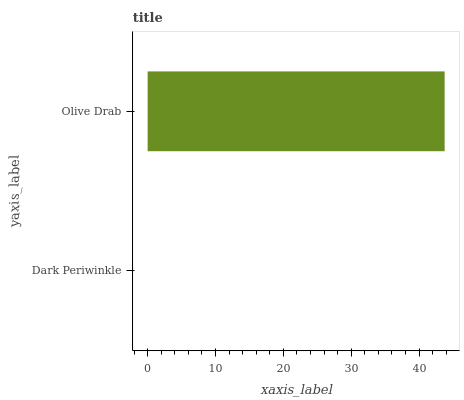Is Dark Periwinkle the minimum?
Answer yes or no. Yes. Is Olive Drab the maximum?
Answer yes or no. Yes. Is Olive Drab the minimum?
Answer yes or no. No. Is Olive Drab greater than Dark Periwinkle?
Answer yes or no. Yes. Is Dark Periwinkle less than Olive Drab?
Answer yes or no. Yes. Is Dark Periwinkle greater than Olive Drab?
Answer yes or no. No. Is Olive Drab less than Dark Periwinkle?
Answer yes or no. No. Is Olive Drab the high median?
Answer yes or no. Yes. Is Dark Periwinkle the low median?
Answer yes or no. Yes. Is Dark Periwinkle the high median?
Answer yes or no. No. Is Olive Drab the low median?
Answer yes or no. No. 